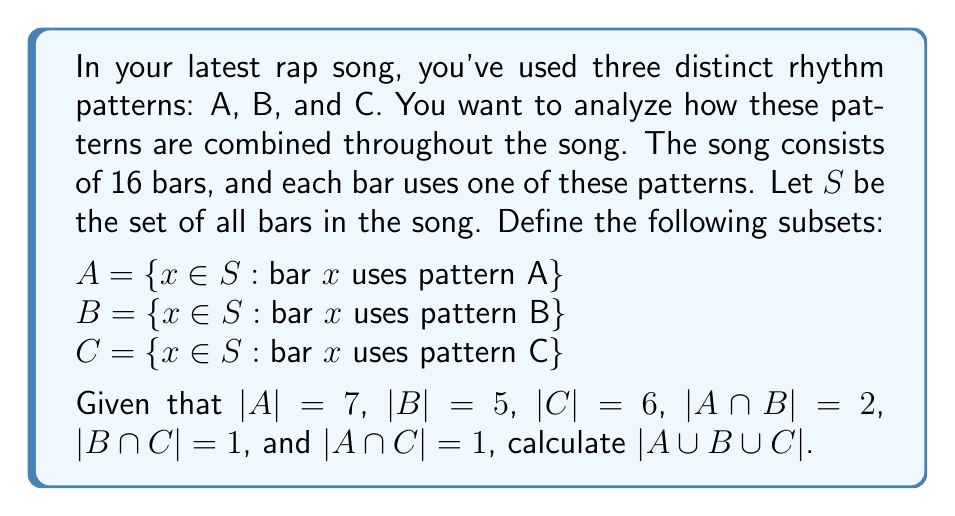Teach me how to tackle this problem. Let's approach this step-by-step using the Inclusion-Exclusion Principle:

1) The Inclusion-Exclusion Principle for three sets states:

   $$|A \cup B \cup C| = |A| + |B| + |C| - |A \cap B| - |B \cap C| - |A \cap C| + |A \cap B \cap C|$$

2) We're given most of these values:
   $|A| = 7$, $|B| = 5$, $|C| = 6$, $|A \cap B| = 2$, $|B \cap C| = 1$, $|A \cap C| = 1$

3) The only value we're missing is $|A \cap B \cap C|$. Let's call this value $x$.

4) We know that the total number of bars in the song is 16. This means:

   $$|A \cup B \cup C| = 16$$

5) Now we can set up our equation:

   $$16 = 7 + 5 + 6 - 2 - 1 - 1 + x$$

6) Simplify:

   $$16 = 14 + x$$

7) Solve for $x$:

   $$x = 16 - 14 = 2$$

8) So, $|A \cap B \cap C| = 2$

9) Now we can plug all values into the Inclusion-Exclusion Principle:

   $$|A \cup B \cup C| = 7 + 5 + 6 - 2 - 1 - 1 + 2 = 16$$

This confirms our original assumption that all 16 bars use one of the three patterns.
Answer: $|A \cup B \cup C| = 16$ 